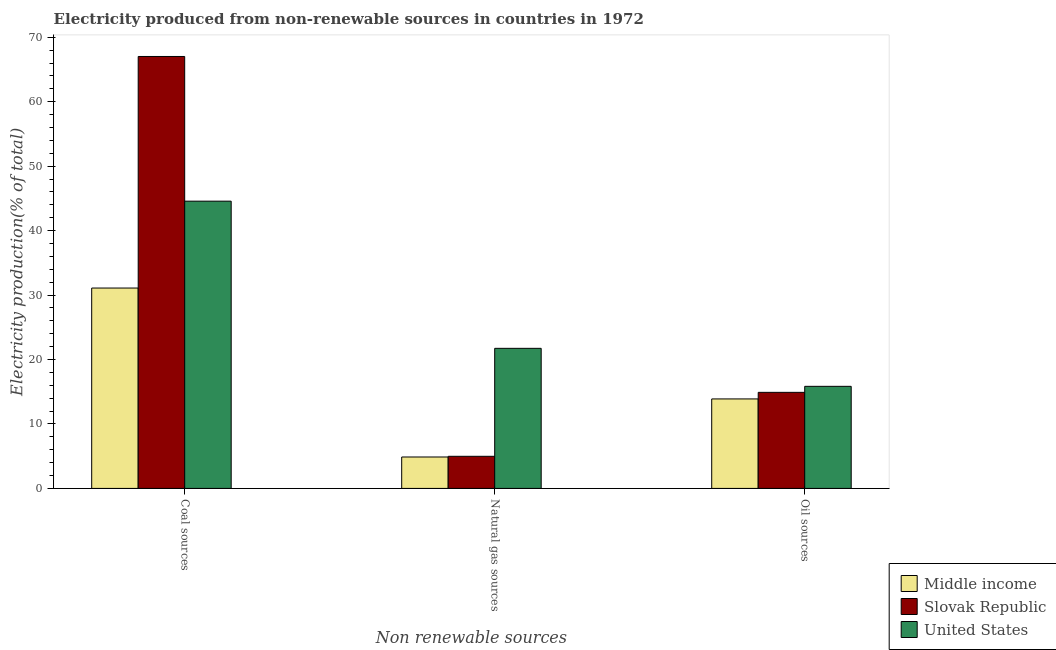How many different coloured bars are there?
Provide a succinct answer. 3. How many groups of bars are there?
Offer a terse response. 3. Are the number of bars per tick equal to the number of legend labels?
Keep it short and to the point. Yes. Are the number of bars on each tick of the X-axis equal?
Make the answer very short. Yes. What is the label of the 3rd group of bars from the left?
Provide a short and direct response. Oil sources. What is the percentage of electricity produced by natural gas in Middle income?
Your answer should be very brief. 4.88. Across all countries, what is the maximum percentage of electricity produced by oil sources?
Your answer should be compact. 15.84. Across all countries, what is the minimum percentage of electricity produced by coal?
Make the answer very short. 31.09. In which country was the percentage of electricity produced by oil sources maximum?
Ensure brevity in your answer.  United States. In which country was the percentage of electricity produced by oil sources minimum?
Your answer should be very brief. Middle income. What is the total percentage of electricity produced by natural gas in the graph?
Offer a very short reply. 31.59. What is the difference between the percentage of electricity produced by coal in Slovak Republic and that in United States?
Your answer should be compact. 22.45. What is the difference between the percentage of electricity produced by oil sources in Middle income and the percentage of electricity produced by natural gas in United States?
Your answer should be compact. -7.85. What is the average percentage of electricity produced by oil sources per country?
Provide a succinct answer. 14.88. What is the difference between the percentage of electricity produced by coal and percentage of electricity produced by oil sources in United States?
Give a very brief answer. 28.73. In how many countries, is the percentage of electricity produced by oil sources greater than 54 %?
Provide a succinct answer. 0. What is the ratio of the percentage of electricity produced by coal in Middle income to that in Slovak Republic?
Provide a succinct answer. 0.46. Is the percentage of electricity produced by natural gas in Slovak Republic less than that in Middle income?
Make the answer very short. No. Is the difference between the percentage of electricity produced by coal in United States and Slovak Republic greater than the difference between the percentage of electricity produced by natural gas in United States and Slovak Republic?
Give a very brief answer. No. What is the difference between the highest and the second highest percentage of electricity produced by natural gas?
Keep it short and to the point. 16.75. What is the difference between the highest and the lowest percentage of electricity produced by natural gas?
Give a very brief answer. 16.86. In how many countries, is the percentage of electricity produced by natural gas greater than the average percentage of electricity produced by natural gas taken over all countries?
Your answer should be very brief. 1. What does the 1st bar from the left in Natural gas sources represents?
Provide a short and direct response. Middle income. What does the 2nd bar from the right in Oil sources represents?
Ensure brevity in your answer.  Slovak Republic. Are all the bars in the graph horizontal?
Offer a very short reply. No. Are the values on the major ticks of Y-axis written in scientific E-notation?
Provide a succinct answer. No. Does the graph contain grids?
Offer a very short reply. No. How many legend labels are there?
Your answer should be compact. 3. How are the legend labels stacked?
Make the answer very short. Vertical. What is the title of the graph?
Your answer should be very brief. Electricity produced from non-renewable sources in countries in 1972. What is the label or title of the X-axis?
Provide a succinct answer. Non renewable sources. What is the Electricity production(% of total) of Middle income in Coal sources?
Make the answer very short. 31.09. What is the Electricity production(% of total) of Slovak Republic in Coal sources?
Give a very brief answer. 67.01. What is the Electricity production(% of total) of United States in Coal sources?
Your answer should be very brief. 44.57. What is the Electricity production(% of total) of Middle income in Natural gas sources?
Offer a terse response. 4.88. What is the Electricity production(% of total) in Slovak Republic in Natural gas sources?
Ensure brevity in your answer.  4.98. What is the Electricity production(% of total) of United States in Natural gas sources?
Your answer should be compact. 21.73. What is the Electricity production(% of total) in Middle income in Oil sources?
Ensure brevity in your answer.  13.88. What is the Electricity production(% of total) of Slovak Republic in Oil sources?
Keep it short and to the point. 14.9. What is the Electricity production(% of total) of United States in Oil sources?
Your answer should be very brief. 15.84. Across all Non renewable sources, what is the maximum Electricity production(% of total) in Middle income?
Offer a very short reply. 31.09. Across all Non renewable sources, what is the maximum Electricity production(% of total) in Slovak Republic?
Your answer should be compact. 67.01. Across all Non renewable sources, what is the maximum Electricity production(% of total) of United States?
Offer a very short reply. 44.57. Across all Non renewable sources, what is the minimum Electricity production(% of total) of Middle income?
Your answer should be very brief. 4.88. Across all Non renewable sources, what is the minimum Electricity production(% of total) in Slovak Republic?
Offer a terse response. 4.98. Across all Non renewable sources, what is the minimum Electricity production(% of total) of United States?
Give a very brief answer. 15.84. What is the total Electricity production(% of total) in Middle income in the graph?
Provide a short and direct response. 49.85. What is the total Electricity production(% of total) in Slovak Republic in the graph?
Make the answer very short. 86.9. What is the total Electricity production(% of total) in United States in the graph?
Your answer should be very brief. 82.14. What is the difference between the Electricity production(% of total) of Middle income in Coal sources and that in Natural gas sources?
Provide a succinct answer. 26.21. What is the difference between the Electricity production(% of total) in Slovak Republic in Coal sources and that in Natural gas sources?
Provide a succinct answer. 62.03. What is the difference between the Electricity production(% of total) in United States in Coal sources and that in Natural gas sources?
Keep it short and to the point. 22.83. What is the difference between the Electricity production(% of total) of Middle income in Coal sources and that in Oil sources?
Provide a short and direct response. 17.2. What is the difference between the Electricity production(% of total) in Slovak Republic in Coal sources and that in Oil sources?
Give a very brief answer. 52.11. What is the difference between the Electricity production(% of total) in United States in Coal sources and that in Oil sources?
Your answer should be very brief. 28.73. What is the difference between the Electricity production(% of total) in Middle income in Natural gas sources and that in Oil sources?
Make the answer very short. -9.01. What is the difference between the Electricity production(% of total) in Slovak Republic in Natural gas sources and that in Oil sources?
Your response must be concise. -9.92. What is the difference between the Electricity production(% of total) of United States in Natural gas sources and that in Oil sources?
Provide a short and direct response. 5.9. What is the difference between the Electricity production(% of total) in Middle income in Coal sources and the Electricity production(% of total) in Slovak Republic in Natural gas sources?
Offer a terse response. 26.11. What is the difference between the Electricity production(% of total) of Middle income in Coal sources and the Electricity production(% of total) of United States in Natural gas sources?
Your answer should be compact. 9.35. What is the difference between the Electricity production(% of total) of Slovak Republic in Coal sources and the Electricity production(% of total) of United States in Natural gas sources?
Make the answer very short. 45.28. What is the difference between the Electricity production(% of total) of Middle income in Coal sources and the Electricity production(% of total) of Slovak Republic in Oil sources?
Make the answer very short. 16.18. What is the difference between the Electricity production(% of total) of Middle income in Coal sources and the Electricity production(% of total) of United States in Oil sources?
Offer a very short reply. 15.25. What is the difference between the Electricity production(% of total) of Slovak Republic in Coal sources and the Electricity production(% of total) of United States in Oil sources?
Offer a terse response. 51.18. What is the difference between the Electricity production(% of total) in Middle income in Natural gas sources and the Electricity production(% of total) in Slovak Republic in Oil sources?
Provide a succinct answer. -10.03. What is the difference between the Electricity production(% of total) of Middle income in Natural gas sources and the Electricity production(% of total) of United States in Oil sources?
Your answer should be very brief. -10.96. What is the difference between the Electricity production(% of total) of Slovak Republic in Natural gas sources and the Electricity production(% of total) of United States in Oil sources?
Your answer should be compact. -10.86. What is the average Electricity production(% of total) in Middle income per Non renewable sources?
Offer a very short reply. 16.62. What is the average Electricity production(% of total) of Slovak Republic per Non renewable sources?
Your answer should be very brief. 28.97. What is the average Electricity production(% of total) in United States per Non renewable sources?
Provide a short and direct response. 27.38. What is the difference between the Electricity production(% of total) in Middle income and Electricity production(% of total) in Slovak Republic in Coal sources?
Keep it short and to the point. -35.93. What is the difference between the Electricity production(% of total) in Middle income and Electricity production(% of total) in United States in Coal sources?
Your response must be concise. -13.48. What is the difference between the Electricity production(% of total) in Slovak Republic and Electricity production(% of total) in United States in Coal sources?
Make the answer very short. 22.45. What is the difference between the Electricity production(% of total) of Middle income and Electricity production(% of total) of Slovak Republic in Natural gas sources?
Ensure brevity in your answer.  -0.11. What is the difference between the Electricity production(% of total) in Middle income and Electricity production(% of total) in United States in Natural gas sources?
Provide a short and direct response. -16.86. What is the difference between the Electricity production(% of total) in Slovak Republic and Electricity production(% of total) in United States in Natural gas sources?
Make the answer very short. -16.75. What is the difference between the Electricity production(% of total) of Middle income and Electricity production(% of total) of Slovak Republic in Oil sources?
Your answer should be compact. -1.02. What is the difference between the Electricity production(% of total) of Middle income and Electricity production(% of total) of United States in Oil sources?
Offer a very short reply. -1.95. What is the difference between the Electricity production(% of total) of Slovak Republic and Electricity production(% of total) of United States in Oil sources?
Provide a succinct answer. -0.93. What is the ratio of the Electricity production(% of total) of Middle income in Coal sources to that in Natural gas sources?
Give a very brief answer. 6.38. What is the ratio of the Electricity production(% of total) in Slovak Republic in Coal sources to that in Natural gas sources?
Make the answer very short. 13.45. What is the ratio of the Electricity production(% of total) in United States in Coal sources to that in Natural gas sources?
Offer a terse response. 2.05. What is the ratio of the Electricity production(% of total) in Middle income in Coal sources to that in Oil sources?
Provide a short and direct response. 2.24. What is the ratio of the Electricity production(% of total) of Slovak Republic in Coal sources to that in Oil sources?
Provide a succinct answer. 4.5. What is the ratio of the Electricity production(% of total) of United States in Coal sources to that in Oil sources?
Offer a terse response. 2.81. What is the ratio of the Electricity production(% of total) of Middle income in Natural gas sources to that in Oil sources?
Your answer should be very brief. 0.35. What is the ratio of the Electricity production(% of total) in Slovak Republic in Natural gas sources to that in Oil sources?
Offer a terse response. 0.33. What is the ratio of the Electricity production(% of total) in United States in Natural gas sources to that in Oil sources?
Your answer should be very brief. 1.37. What is the difference between the highest and the second highest Electricity production(% of total) of Middle income?
Your answer should be compact. 17.2. What is the difference between the highest and the second highest Electricity production(% of total) in Slovak Republic?
Offer a terse response. 52.11. What is the difference between the highest and the second highest Electricity production(% of total) of United States?
Provide a succinct answer. 22.83. What is the difference between the highest and the lowest Electricity production(% of total) in Middle income?
Your answer should be compact. 26.21. What is the difference between the highest and the lowest Electricity production(% of total) of Slovak Republic?
Ensure brevity in your answer.  62.03. What is the difference between the highest and the lowest Electricity production(% of total) in United States?
Offer a very short reply. 28.73. 